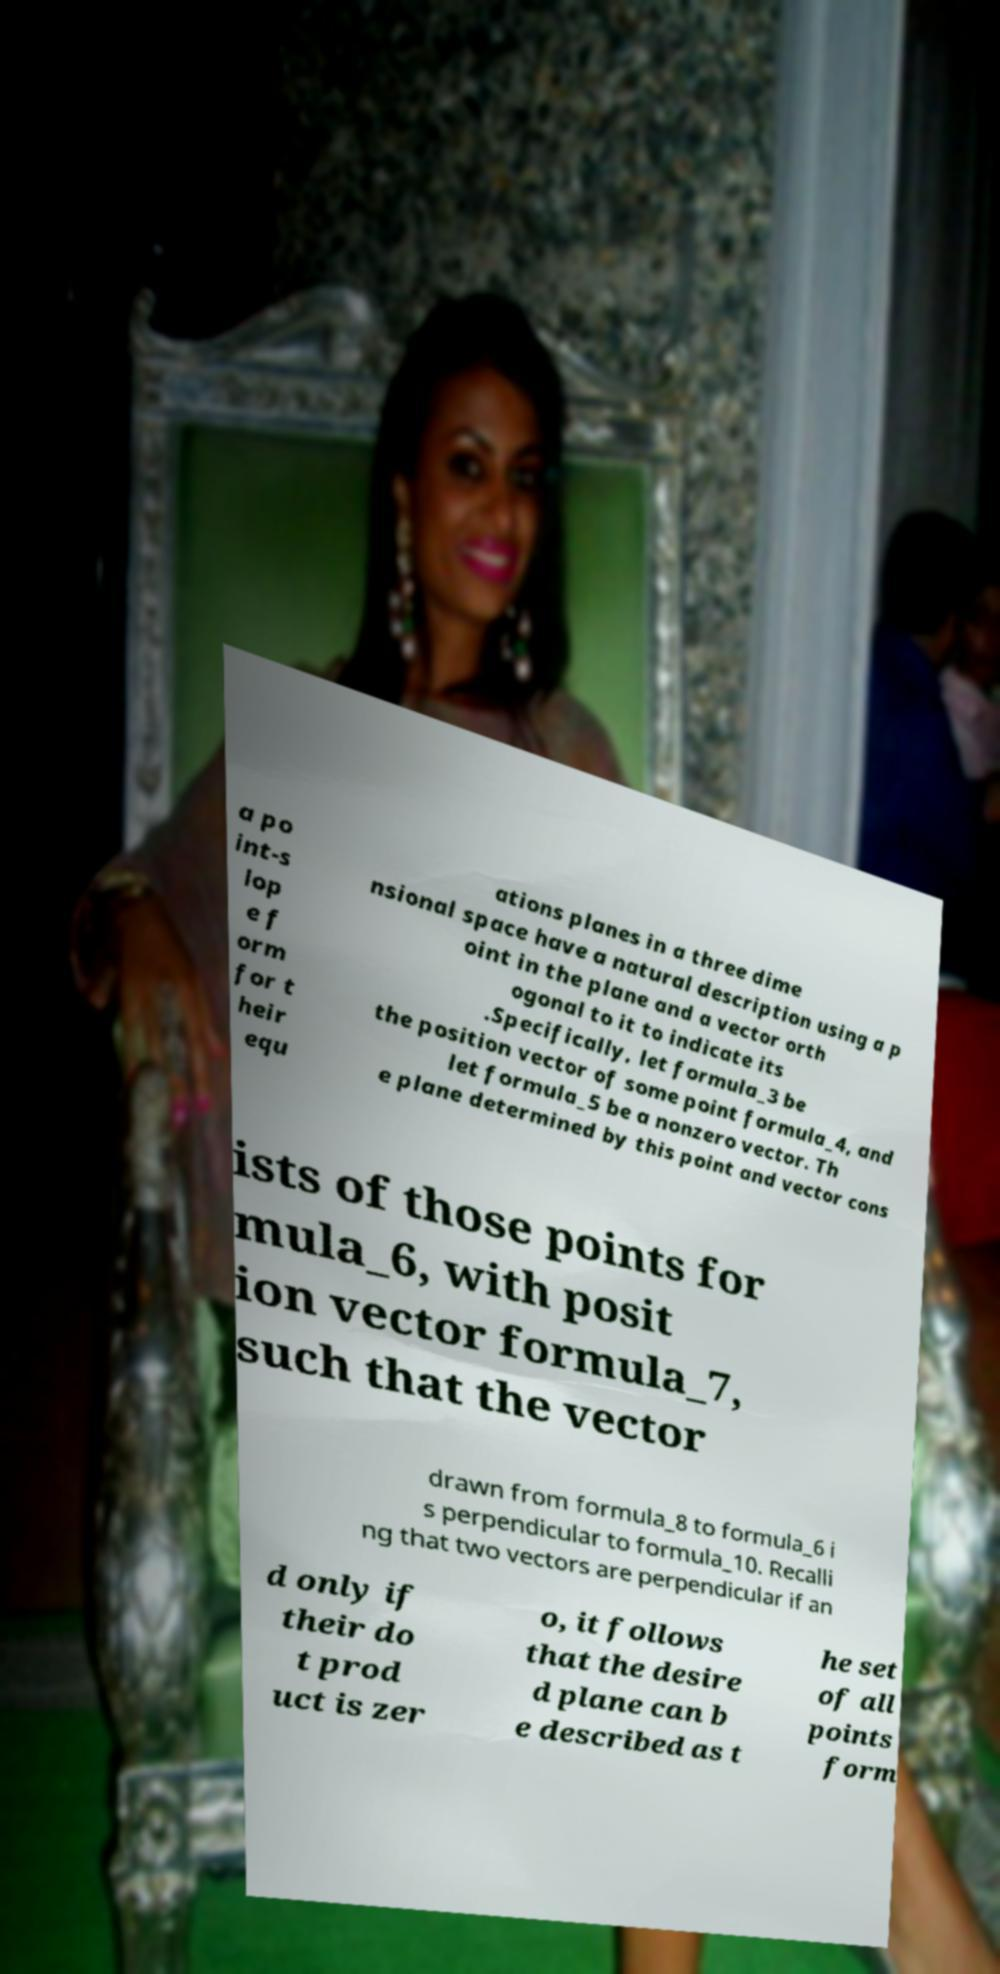What messages or text are displayed in this image? I need them in a readable, typed format. a po int-s lop e f orm for t heir equ ations planes in a three dime nsional space have a natural description using a p oint in the plane and a vector orth ogonal to it to indicate its .Specifically, let formula_3 be the position vector of some point formula_4, and let formula_5 be a nonzero vector. Th e plane determined by this point and vector cons ists of those points for mula_6, with posit ion vector formula_7, such that the vector drawn from formula_8 to formula_6 i s perpendicular to formula_10. Recalli ng that two vectors are perpendicular if an d only if their do t prod uct is zer o, it follows that the desire d plane can b e described as t he set of all points form 